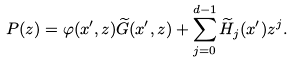<formula> <loc_0><loc_0><loc_500><loc_500>P ( z ) = \varphi ( x ^ { \prime } , z ) \widetilde { G } ( x ^ { \prime } , z ) + \sum _ { j = 0 } ^ { d - 1 } \widetilde { H } _ { j } ( x ^ { \prime } ) z ^ { j } .</formula> 